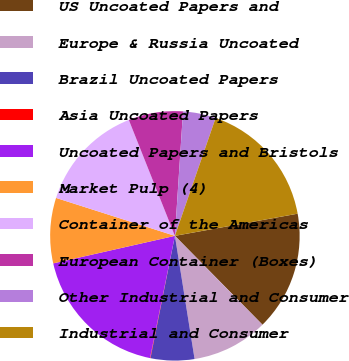<chart> <loc_0><loc_0><loc_500><loc_500><pie_chart><fcel>US Uncoated Papers and<fcel>Europe & Russia Uncoated<fcel>Brazil Uncoated Papers<fcel>Asia Uncoated Papers<fcel>Uncoated Papers and Bristols<fcel>Market Pulp (4)<fcel>Container of the Americas<fcel>European Container (Boxes)<fcel>Other Industrial and Consumer<fcel>Industrial and Consumer<nl><fcel>15.46%<fcel>9.86%<fcel>5.66%<fcel>0.06%<fcel>18.26%<fcel>8.46%<fcel>14.06%<fcel>7.06%<fcel>4.26%<fcel>16.86%<nl></chart> 